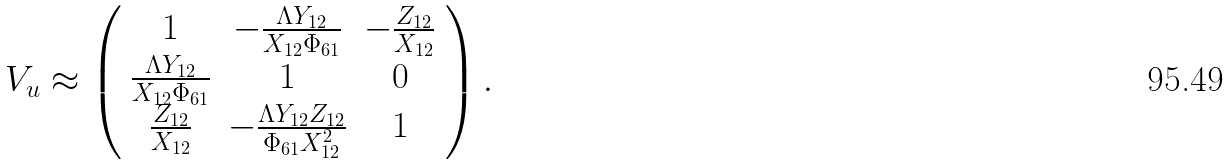Convert formula to latex. <formula><loc_0><loc_0><loc_500><loc_500>V _ { u } \approx \left ( \begin{array} { c c c } 1 & - \frac { \Lambda Y _ { 1 2 } } { X _ { 1 2 } \Phi _ { 6 1 } } & - \frac { Z _ { 1 2 } } { X _ { 1 2 } } \\ \frac { \Lambda Y _ { 1 2 } } { X _ { 1 2 } \Phi _ { 6 1 } } & 1 & 0 \\ \frac { Z _ { 1 2 } } { X _ { 1 2 } } & - \frac { \Lambda Y _ { 1 2 } Z _ { 1 2 } } { \Phi _ { 6 1 } X _ { 1 2 } ^ { 2 } } & 1 \end{array} \right ) .</formula> 